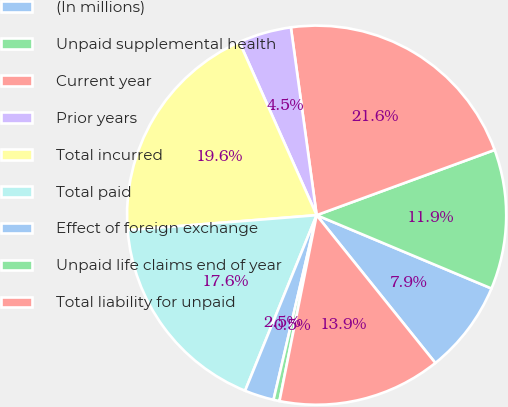<chart> <loc_0><loc_0><loc_500><loc_500><pie_chart><fcel>(In millions)<fcel>Unpaid supplemental health<fcel>Current year<fcel>Prior years<fcel>Total incurred<fcel>Total paid<fcel>Effect of foreign exchange<fcel>Unpaid life claims end of year<fcel>Total liability for unpaid<nl><fcel>7.91%<fcel>11.91%<fcel>21.58%<fcel>4.51%<fcel>19.58%<fcel>17.58%<fcel>2.51%<fcel>0.51%<fcel>13.91%<nl></chart> 